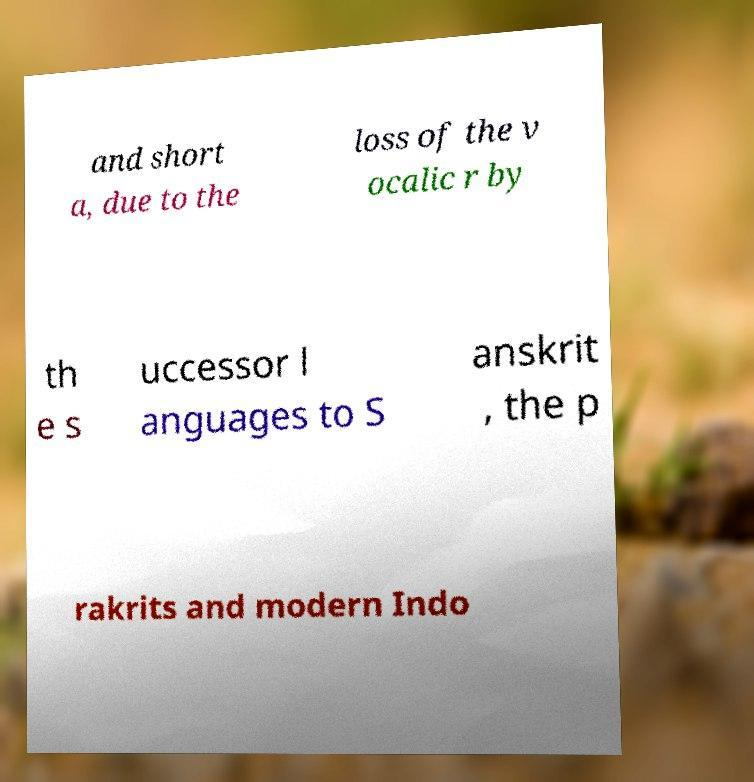I need the written content from this picture converted into text. Can you do that? and short a, due to the loss of the v ocalic r by th e s uccessor l anguages to S anskrit , the p rakrits and modern Indo 